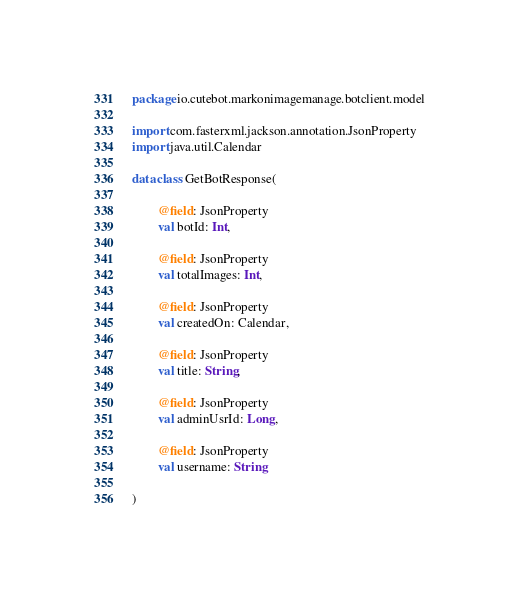Convert code to text. <code><loc_0><loc_0><loc_500><loc_500><_Kotlin_>package io.cutebot.markonimagemanage.botclient.model

import com.fasterxml.jackson.annotation.JsonProperty
import java.util.Calendar

data class GetBotResponse(

        @field: JsonProperty
        val botId: Int,

        @field: JsonProperty
        val totalImages: Int,

        @field: JsonProperty
        val createdOn: Calendar,

        @field: JsonProperty
        val title: String,

        @field: JsonProperty
        val adminUsrId: Long,

        @field: JsonProperty
        val username: String

)
</code> 